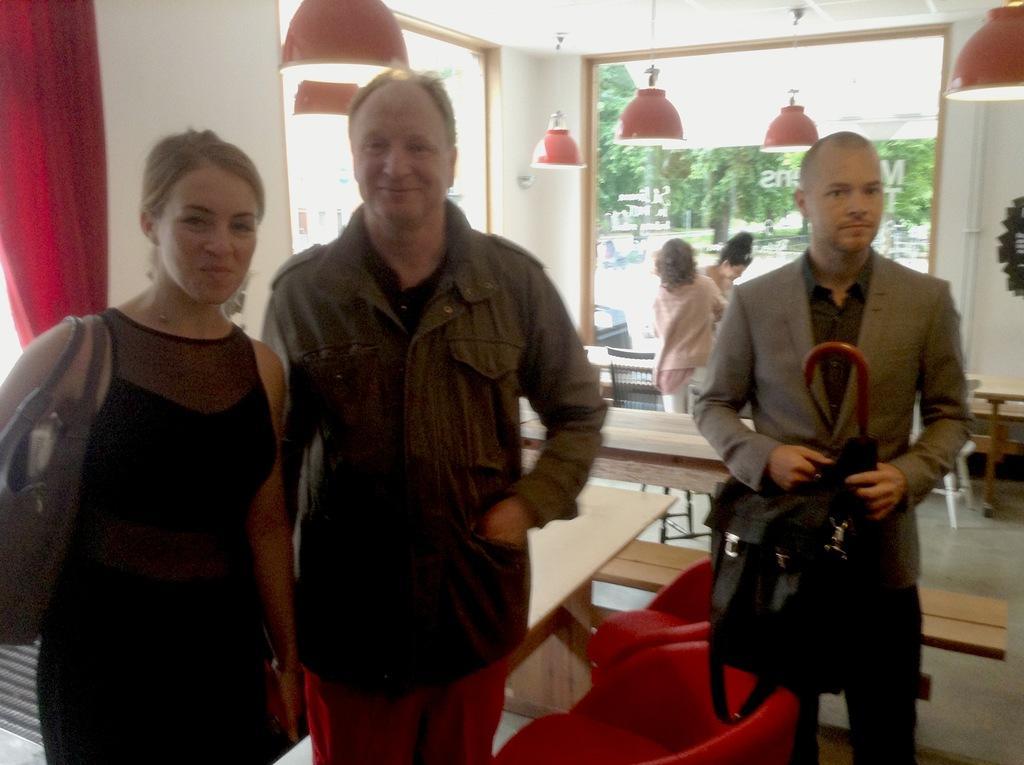How would you summarize this image in a sentence or two? In this picture, we can see three people are standing on the floor and a man is holding an umbrella and a black bag. Behind the people there are chairs, tables, bench, glass window and there are ceiling lights on the top. Through the window we can see the trees. 